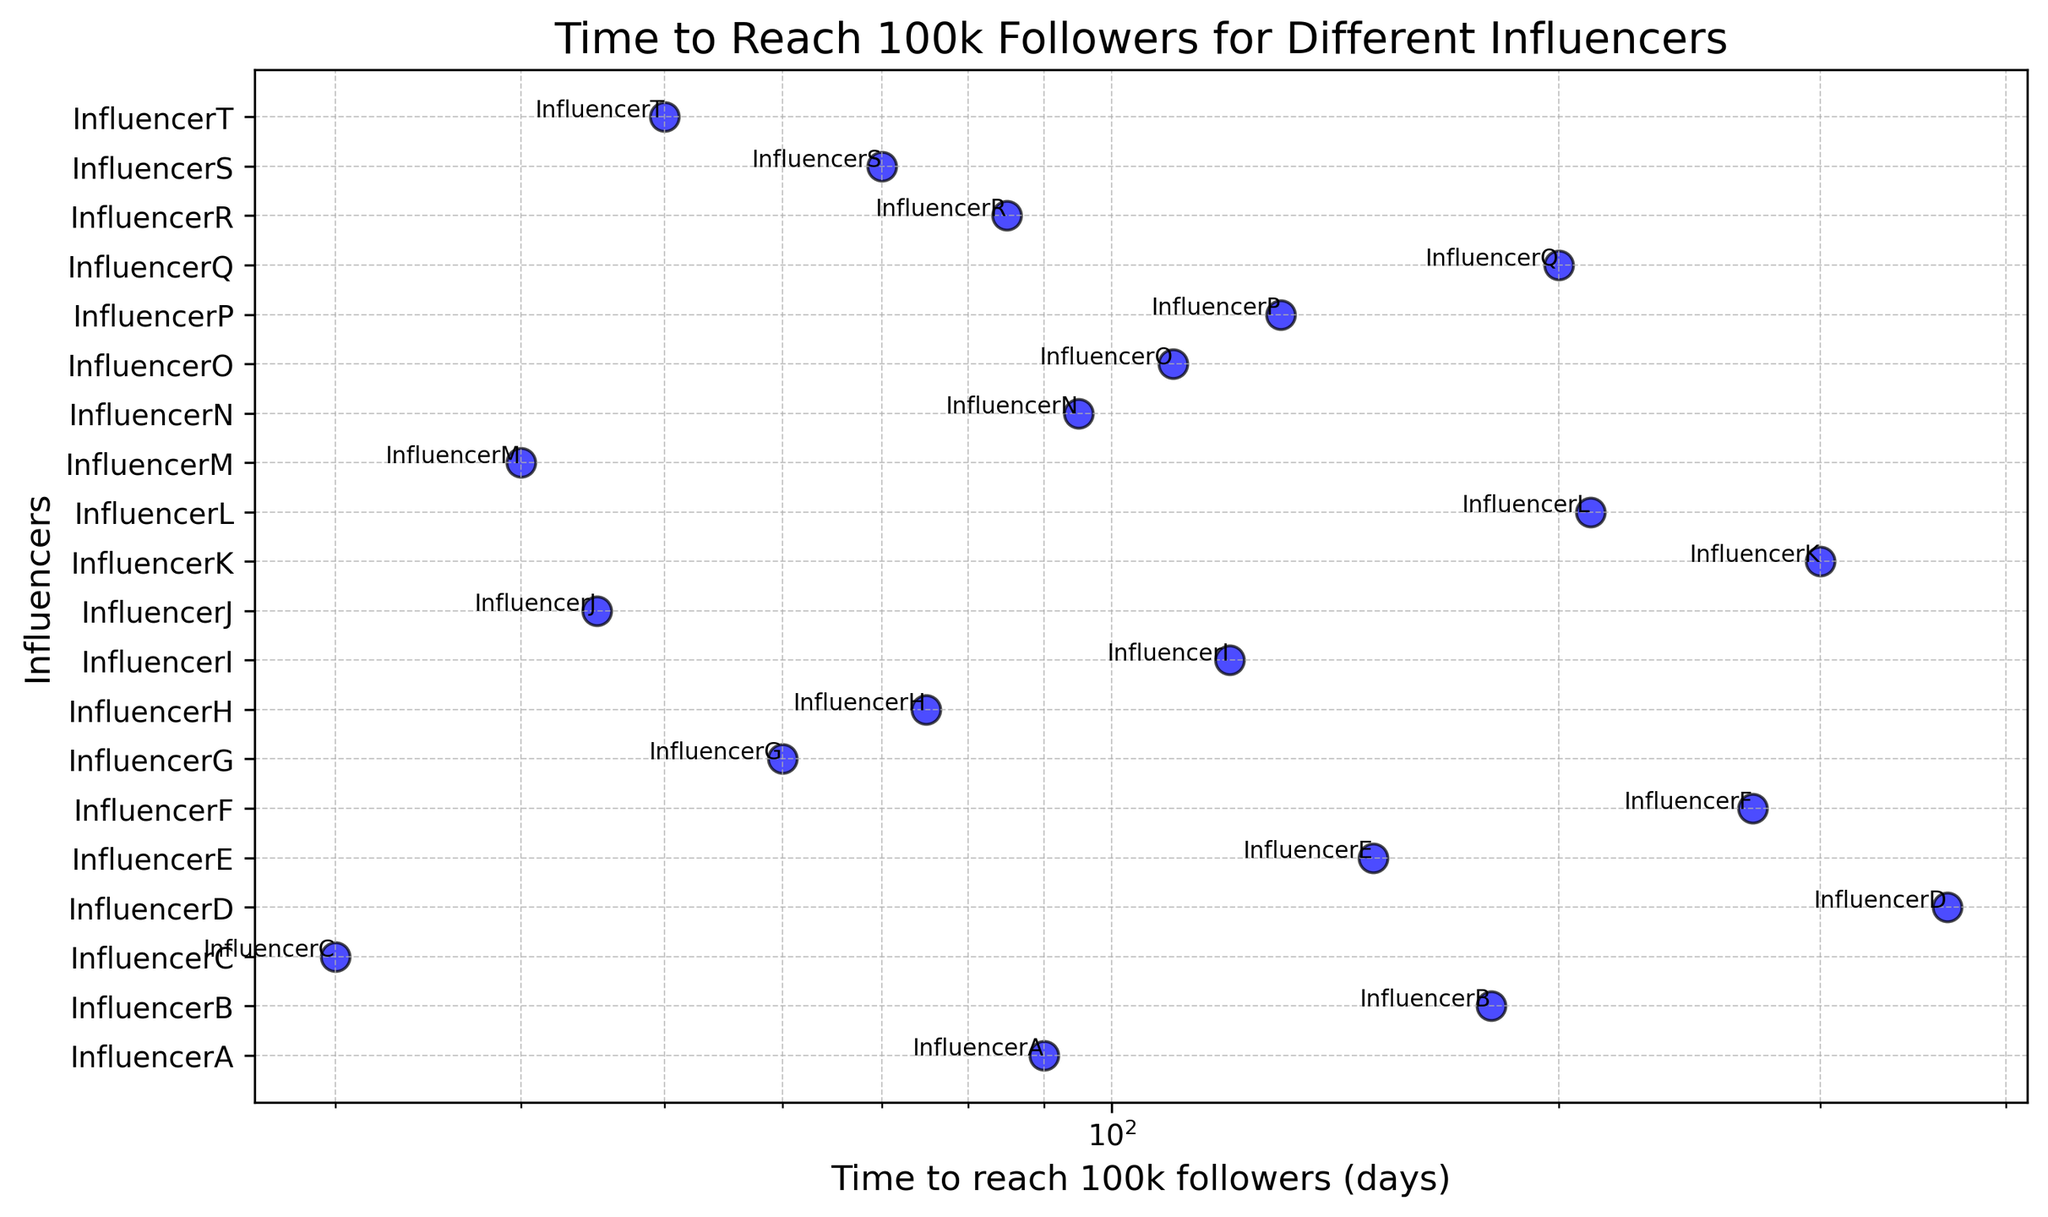What is the time taken by InfluencerC to reach 100k followers? Look at the point labeled "InfluencerC" along the horizontal axis and read off its x-coordinate. InfluencerC is at 30 days.
Answer: 30 days Who reached 100k followers the fastest and in how many days? The influencer with the lowest time to reach 100k followers is the fastest. From the chart, InfluencerC, who reached 100k in 30 days, is the fastest.
Answer: InfluencerC, 30 days Which influencer took the longest time to reach 100k followers? Observe the point farthest to the right on the horizontal axis. InfluencerD is positioned at 365 days.
Answer: InfluencerD How many influencers reached 100k followers in less than 100 days? Identify the points positioned left of the 100-days mark on the horizontal axis. There are eight influencers: InfluencerC, InfluencerJ, InfluencerM, InfluencerT, InfluencerG, InfluencerS, InfluencerH, and InfluencerA.
Answer: 8 influencers Compare the time to reach 100k followers for InfluencerB and InfluencerK. Who took more time, and by how many days? Refer to the x-axis positions of InfluencerB and InfluencerK. InfluencerB took 180 days and InfluencerK took 300 days. The difference is 300 - 180 = 120 days.
Answer: InfluencerK took 120 days more Which influencers reached 100k followers between 50 and 150 days? Look for influencers positioned between the 50 and 150 days marks on the x-axis. Influencers in this range are InfluencerT, InfluencerI, InfluencerE, InfluencerP, InfluencerO, InfluencerR, and InfluencerN.
Answer: 7 influencers What's the median time to reach 100k followers among all influencers? Arrange the times in increasing order: 30, 40, 45, 50, 60, 70, 75, 85, 90, 95, 110, 120, 130, 150, 180, 200, 210, 270, 300, 365. The median is the average of the 10th and 11th values: (95 + 110)/2 = 102.5 days.
Answer: 102.5 days 